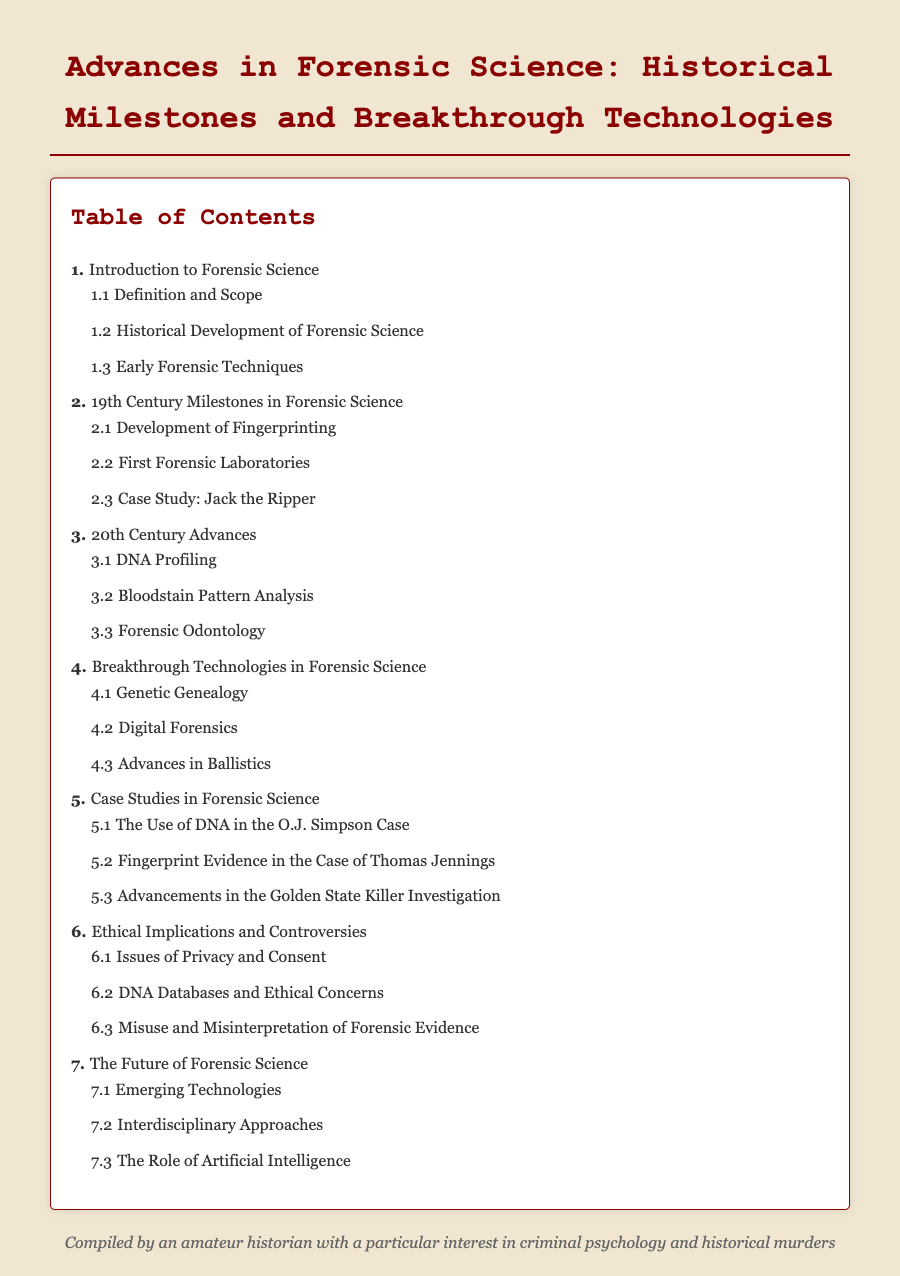What is the first section listed in the Table of Contents? The first section is titled "Introduction to Forensic Science."
Answer: Introduction to Forensic Science How many subsections are in the 19th Century Milestones section? The 19th Century Milestones section contains three subsections.
Answer: 3 What is the title of subsection 4.2? Subsection 4.2 is titled "Digital Forensics."
Answer: Digital Forensics Which case is referenced in subsection 5.2? Subsection 5.2 references the "Case of Thomas Jennings."
Answer: Case of Thomas Jennings What theme does the final section of the document address? The final section addresses "The Future of Forensic Science."
Answer: The Future of Forensic Science Which forensic technique is highlighted in the 20th Century Advances section? The technique highlighted is "DNA Profiling."
Answer: DNA Profiling How many main sections are listed in the Table of Contents? There are seven main sections in the Table of Contents.
Answer: 7 What is the purpose of subsection 6.3? Subsection 6.3 addresses "Misuse and Misinterpretation of Forensic Evidence."
Answer: Misuse and Misinterpretation of Forensic Evidence 